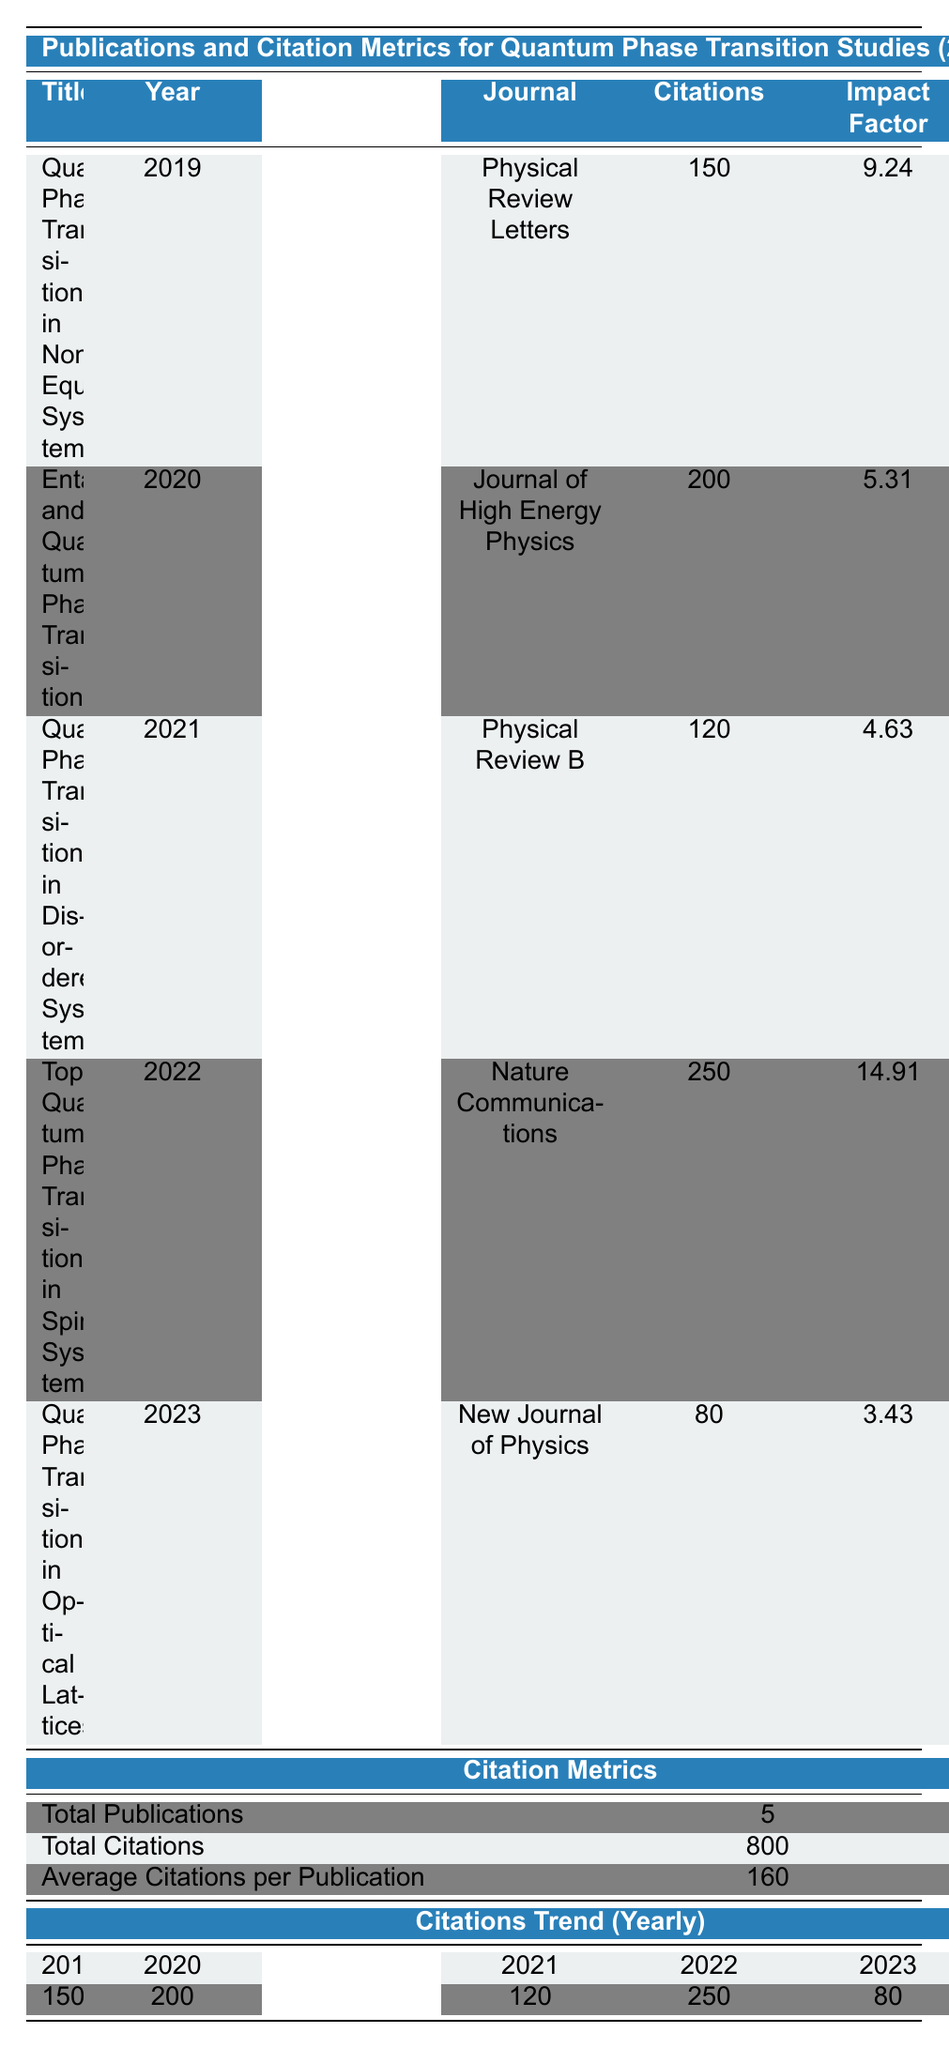What is the total number of publications listed in the table? The table shows a section for Citation Metrics, indicating "Total Publications" as 5.
Answer: 5 Which publication has the highest impact factor? The publication "Topological Quantum Phase Transition in Spin Systems" is listed with an impact factor of 14.91, the highest among all entries.
Answer: Topological Quantum Phase Transition in Spin Systems What year had the least number of citations for quantum phase transition studies? By examining the "Citations Trend (Yearly)" row, 2023 has the least citations, totaling 80.
Answer: 2023 How many total citations were recorded for publications in the year 2020? The table indicates that the publication from 2020, "Entanglement and Quantum Phase Transitions," has 200 citations.
Answer: 200 What is the average number of citations for publications in the table? The "Average Citations per Publication" is calculated as 800 citations divided by 5 publications, which equals 160.
Answer: 160 Is the statement "All publications listed are from high-impact journals" true or false based on the data? The impact factors of the journals range from 3.43 to 14.91. Since some publications have lower impact factors, the statement is false.
Answer: False Which journal published a paper in 2019, and how many citations did it receive? The journal "Physical Review Letters" published "Quantum Phase Transition in Non-Equilibrium Systems" in 2019 with 150 citations.
Answer: Physical Review Letters, 150 What was the trend in citations from 2019 to 2022? The citations increased from 150 in 2019 to 200 in 2020, decreased to 120 in 2021, and then rose sharply to 250 in 2022, showing a fluctuating trend overall.
Answer: Fluctuating trend How does the impact factor of the publication with the most citations compare to the one with the least citations? "Topological Quantum Phase Transition in Spin Systems," with 250 citations, has an impact factor of 14.91, while "Quantum Phase Transitions in Optical Lattices," with only 80 citations, has an impact factor of 3.43. The former has a significantly higher impact factor.
Answer: Significantly higher impact factor What is the total number of citations for publications between 2019 and 2022 combined? Summing the citations: 150 (2019) + 200 (2020) + 120 (2021) + 250 (2022) gives a total of 720 citations.
Answer: 720 